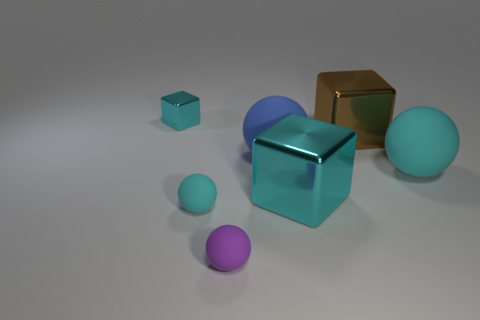What is the material of the large cyan ball?
Your answer should be compact. Rubber. There is a big metallic block in front of the big brown metallic object behind the large cyan ball; are there any rubber objects that are to the right of it?
Provide a short and direct response. Yes. The tiny ball that is made of the same material as the purple object is what color?
Your answer should be compact. Cyan. How many tiny cyan balls have the same material as the small purple thing?
Your answer should be compact. 1. Does the purple sphere have the same material as the cyan cube that is on the left side of the purple rubber ball?
Provide a short and direct response. No. What number of things are rubber spheres that are behind the purple matte sphere or blue spheres?
Ensure brevity in your answer.  3. There is a cyan shiny block on the right side of the small shiny block that is left of the brown metallic thing behind the blue sphere; what size is it?
Provide a short and direct response. Large. What material is the tiny thing that is the same color as the small shiny block?
Make the answer very short. Rubber. What size is the cyan sphere left of the cyan sphere right of the large brown metallic block?
Keep it short and to the point. Small. How many large objects are either yellow rubber blocks or shiny things?
Your answer should be very brief. 2. 